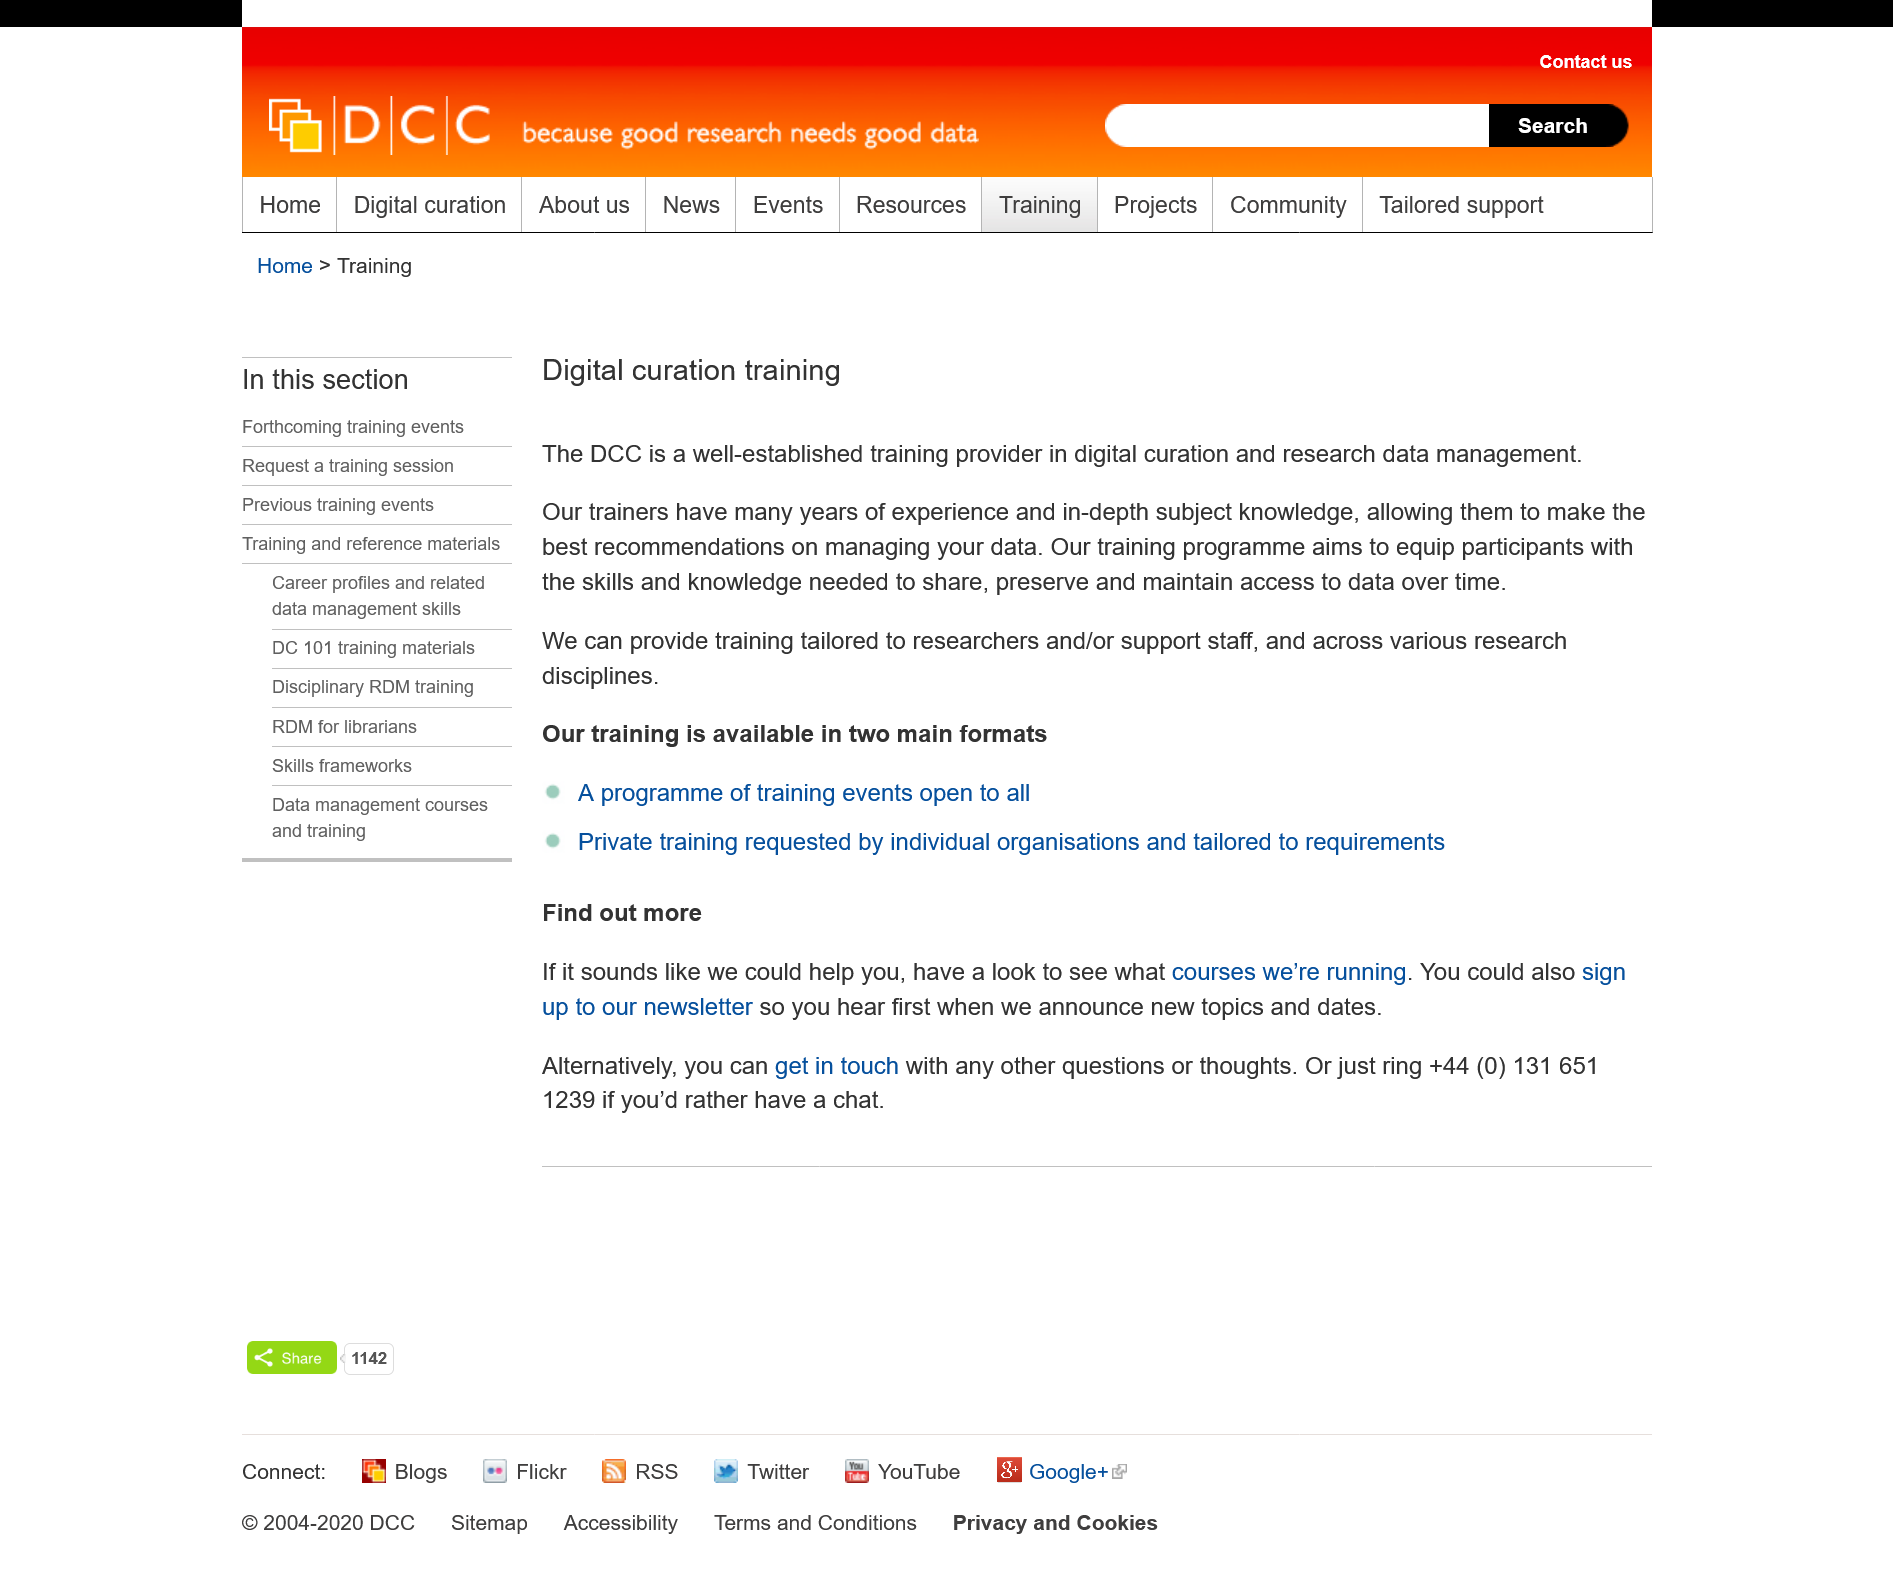List a handful of essential elements in this visual. The DCC is a well-established training provider in digital curation and research data management, and it is recognized as such by the industry. The DCC training programs have the aim of providing participants with the skills and knowledge necessary to effectively share, preserve, and maintain access to data over time. The DCC training is designed to cater to researchers and support staff, with a focus on multiple research disciplines and tailored to meet the needs of each individual. 